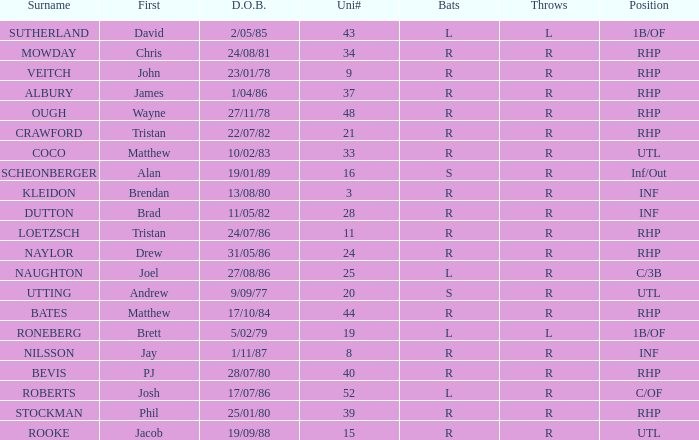How many Uni numbers have Bats of s, and a Position of utl? 1.0. 